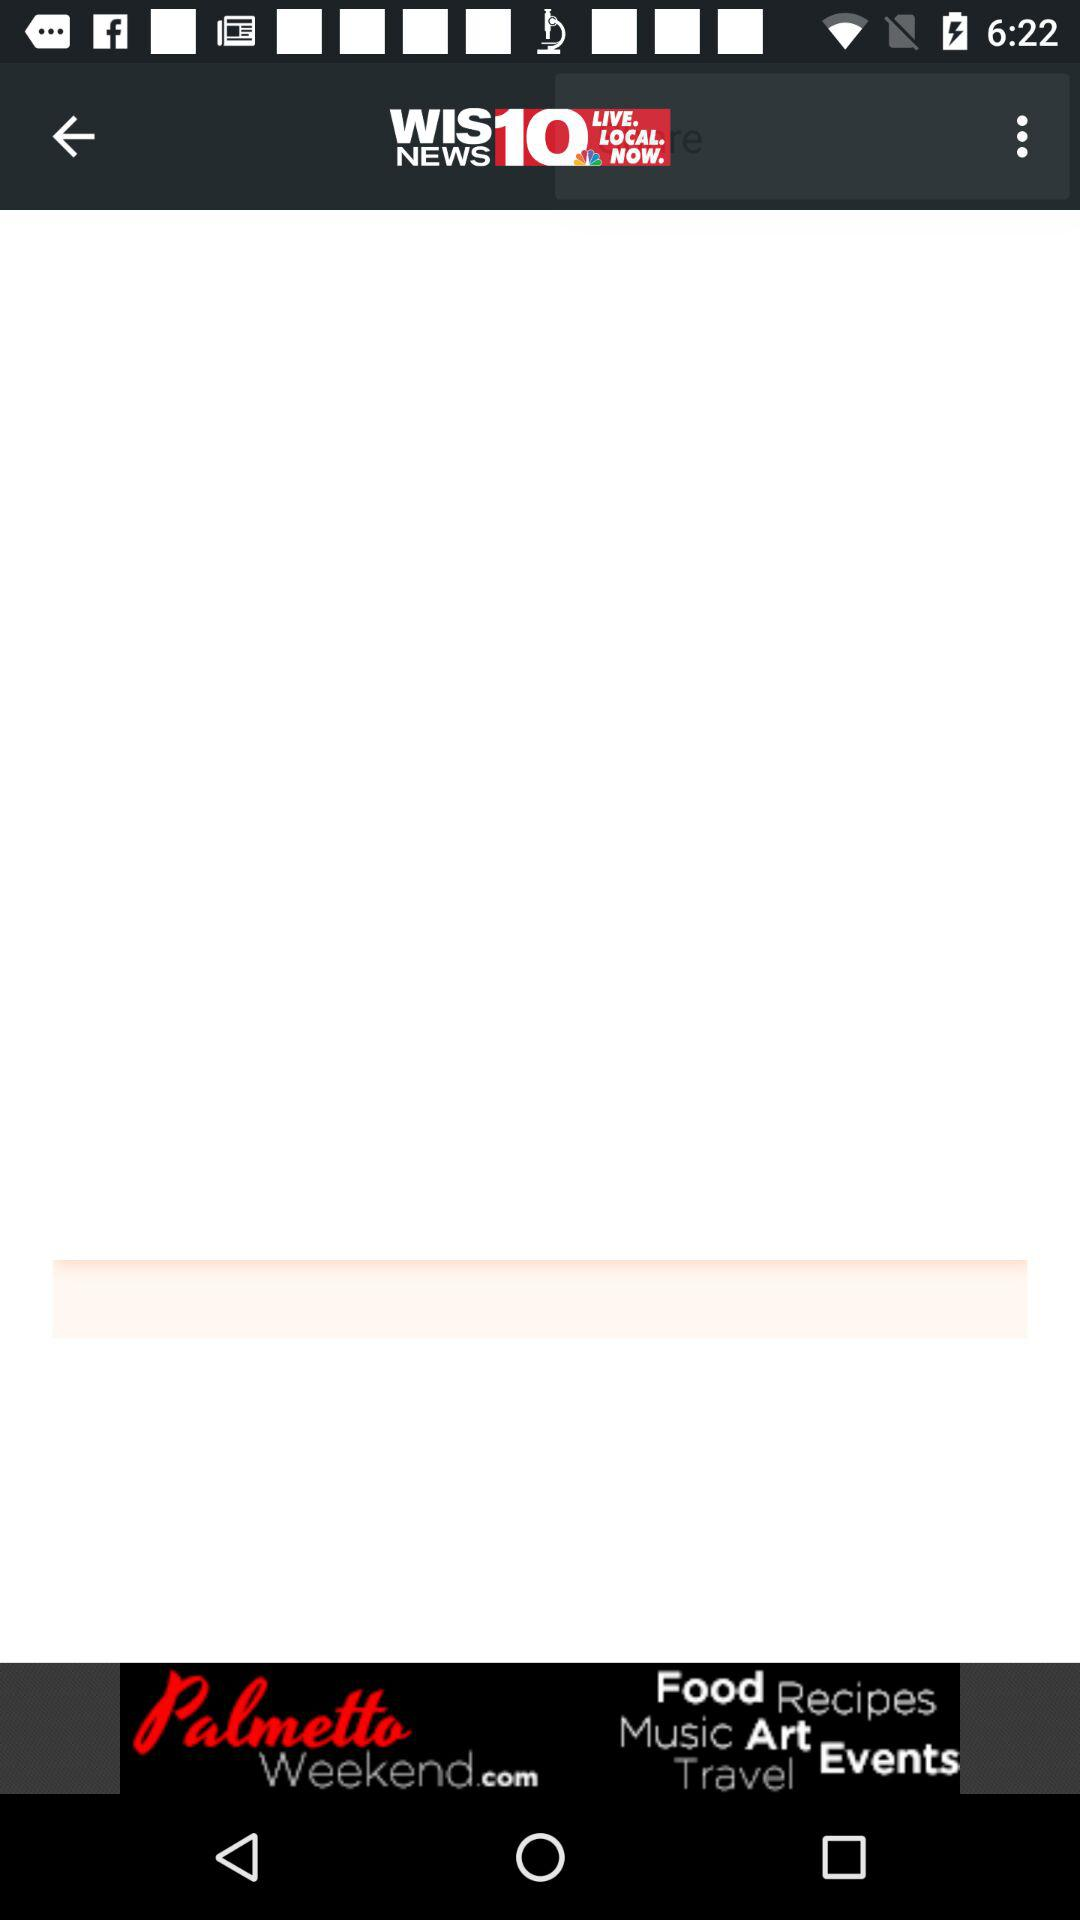What is the name of the application? The application name is "WIS NEWS 10". 